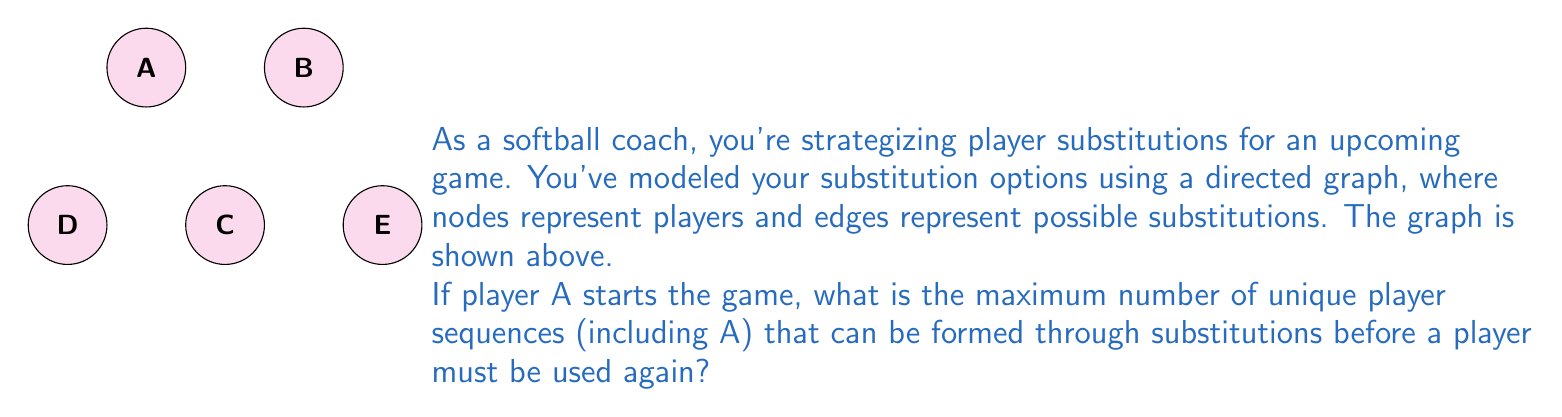Can you solve this math problem? Let's approach this step-by-step:

1) We start with player A. From A, we can go to either C or D.

2) If we go to C:
   - From C, we can go to D or back to A. Going back to A doesn't create a new sequence, so we choose D.
   - From D, we can go to E or back to A. We choose E to maximize the sequence.
   - From E, we have no choice but to stop as there are no outgoing edges.

3) If we go to D from A:
   - From D, we can go to E or back to A. We choose E to maximize the sequence.
   - From E, we have no choice but to stop.

4) The longest sequence starting from A is therefore A-C-D-E.

5) To calculate the number of unique sequences:
   - 1-player sequence: A
   - 2-player sequences: A-C, A-D
   - 3-player sequences: A-C-D, A-D-E
   - 4-player sequence: A-C-D-E

6) In total, we have 1 + 2 + 2 + 1 = 6 unique sequences.

Therefore, the maximum number of unique player sequences starting with A is 6.
Answer: 6 